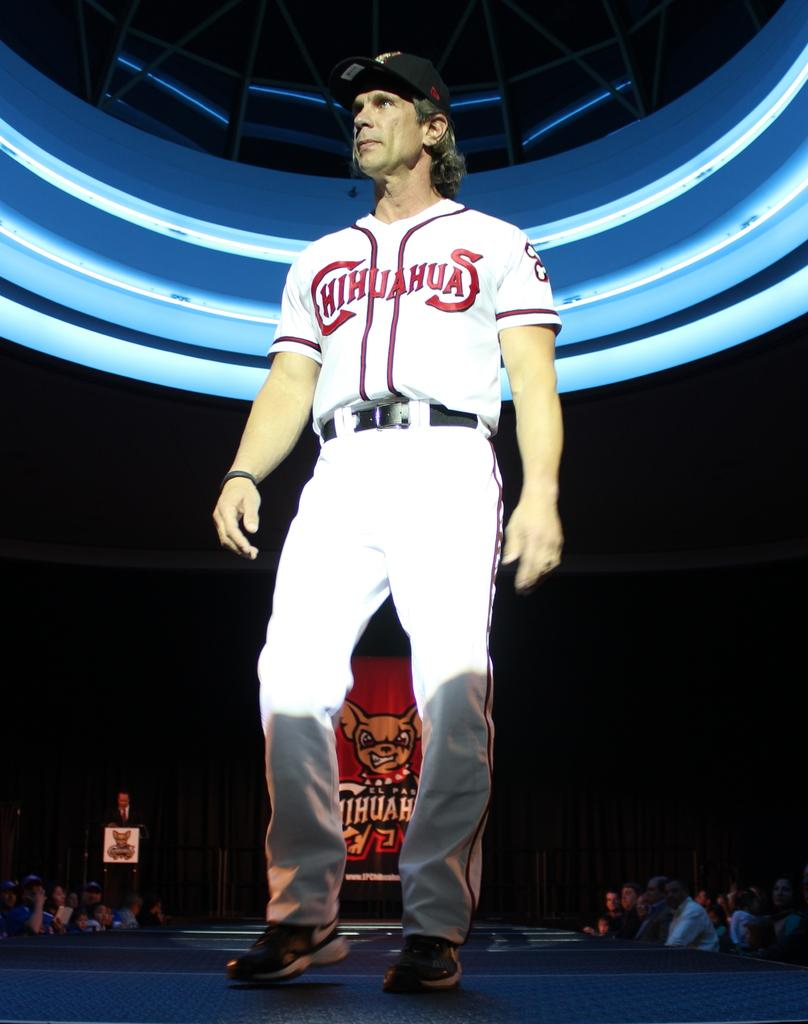<image>
Share a concise interpretation of the image provided. A man in a Chihuahuas jersey stands on a stage by himself. 